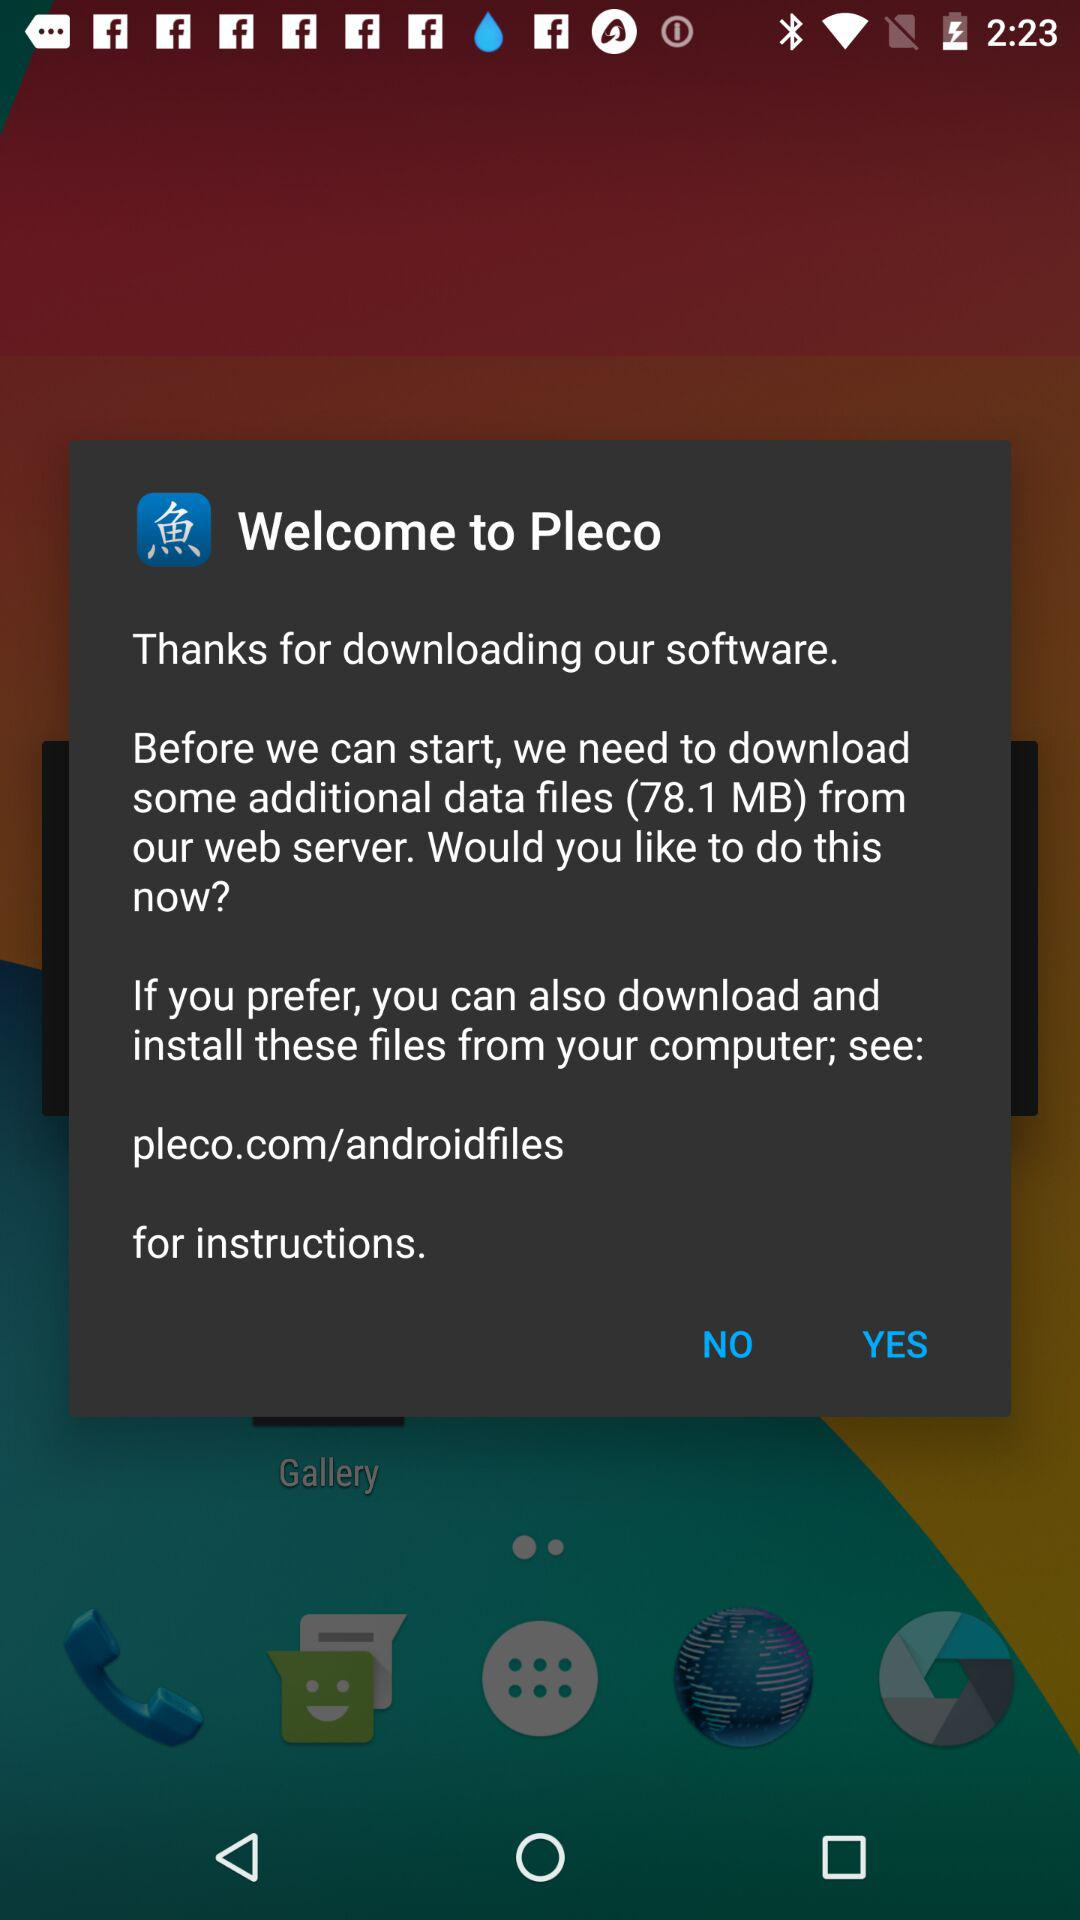How much data is being downloaded, in MB?
Answer the question using a single word or phrase. 78.1 